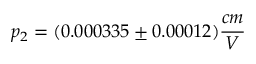Convert formula to latex. <formula><loc_0><loc_0><loc_500><loc_500>p _ { 2 } = ( 0 . 0 0 0 3 3 5 \pm 0 . 0 0 0 1 2 ) \frac { c m } { V }</formula> 